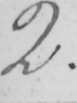Please provide the text content of this handwritten line. 2 . 